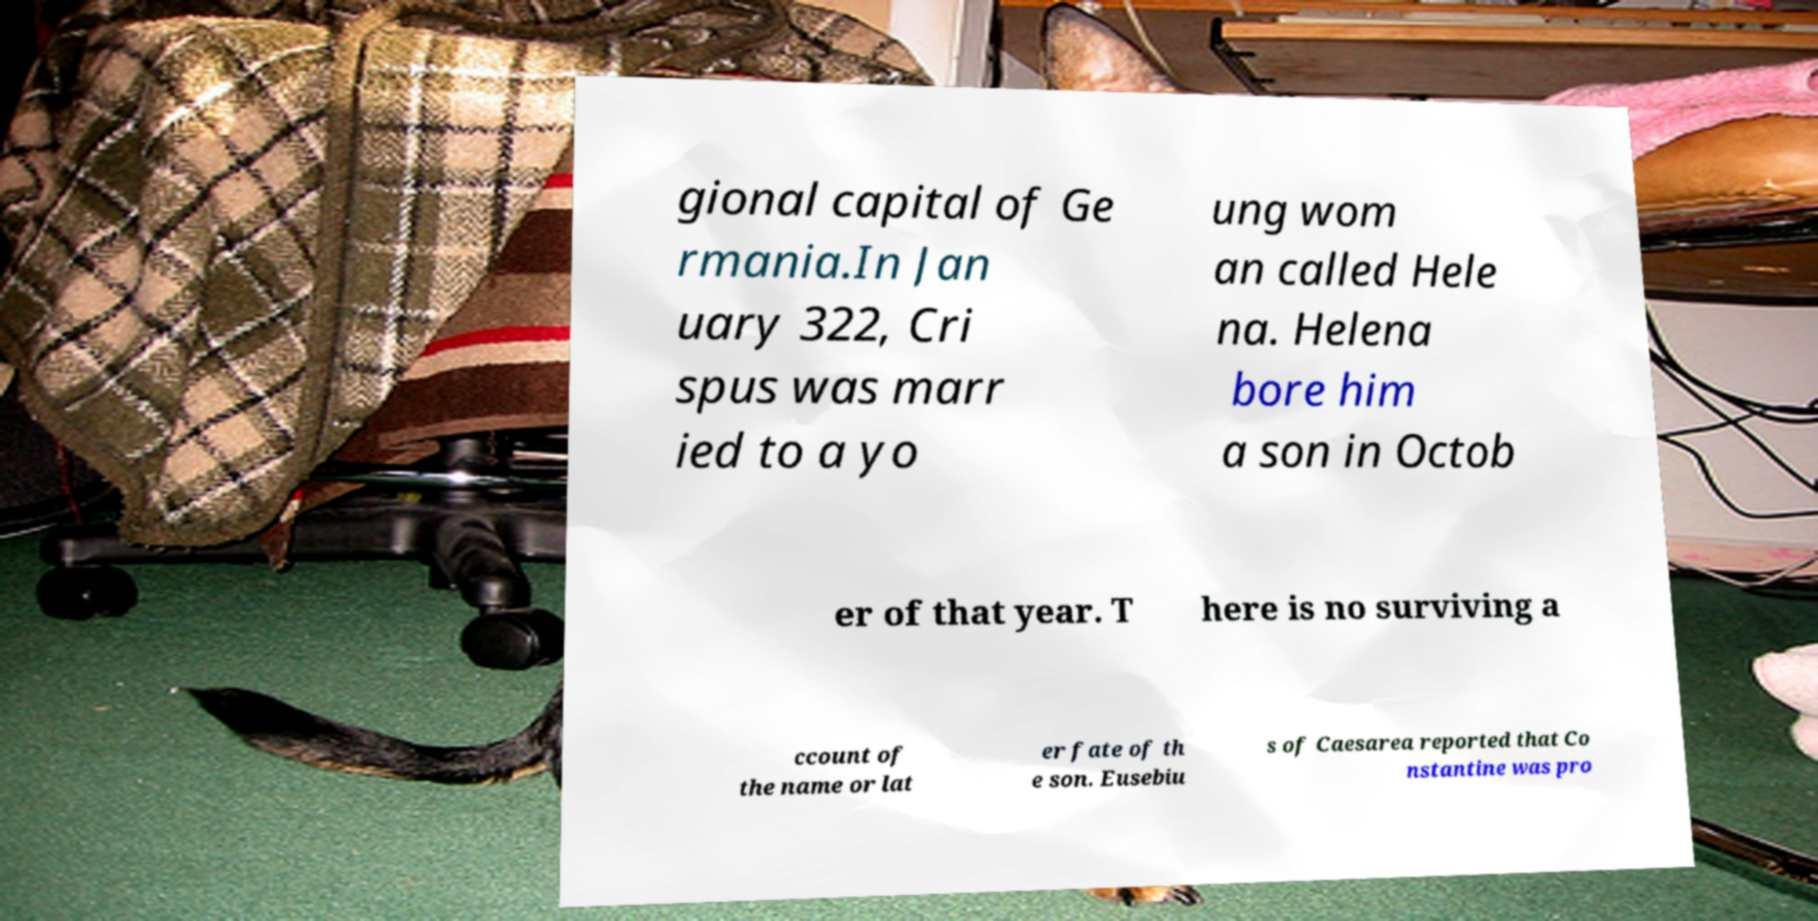I need the written content from this picture converted into text. Can you do that? gional capital of Ge rmania.In Jan uary 322, Cri spus was marr ied to a yo ung wom an called Hele na. Helena bore him a son in Octob er of that year. T here is no surviving a ccount of the name or lat er fate of th e son. Eusebiu s of Caesarea reported that Co nstantine was pro 